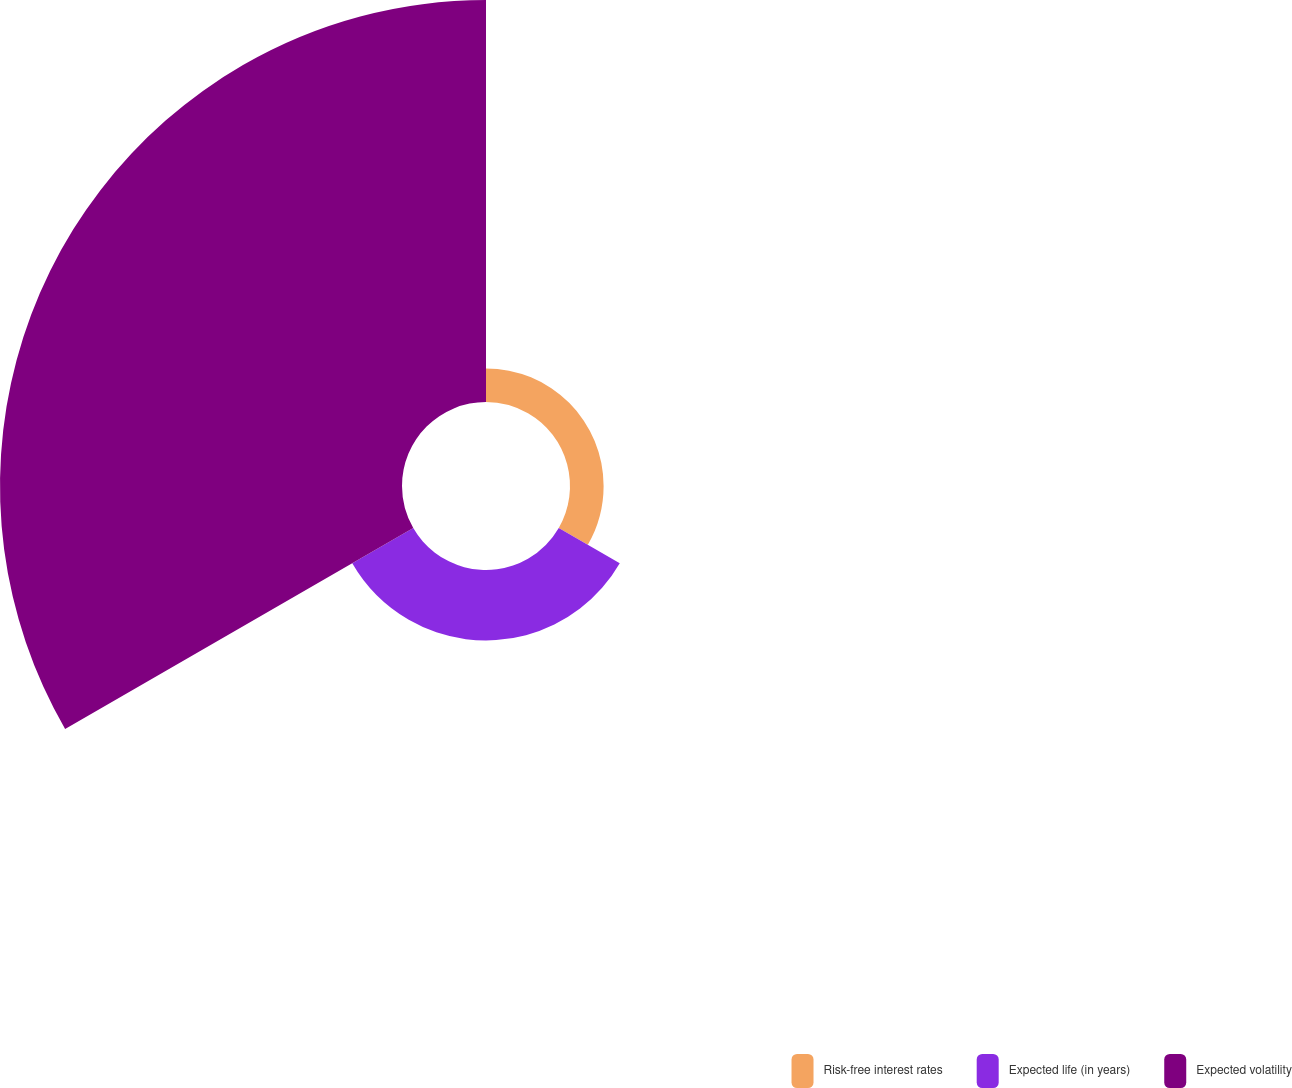Convert chart to OTSL. <chart><loc_0><loc_0><loc_500><loc_500><pie_chart><fcel>Risk-free interest rates<fcel>Expected life (in years)<fcel>Expected volatility<nl><fcel>6.64%<fcel>13.92%<fcel>79.43%<nl></chart> 